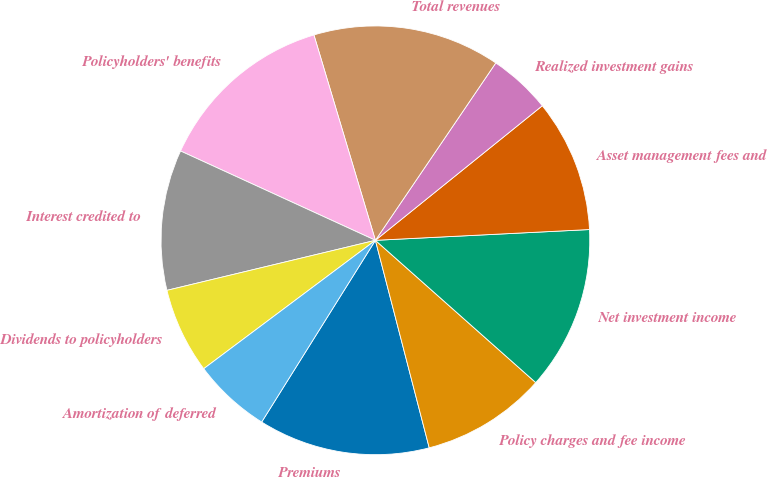Convert chart to OTSL. <chart><loc_0><loc_0><loc_500><loc_500><pie_chart><fcel>Premiums<fcel>Policy charges and fee income<fcel>Net investment income<fcel>Asset management fees and<fcel>Realized investment gains<fcel>Total revenues<fcel>Policyholders' benefits<fcel>Interest credited to<fcel>Dividends to policyholders<fcel>Amortization of deferred<nl><fcel>12.94%<fcel>9.41%<fcel>12.35%<fcel>10.0%<fcel>4.71%<fcel>14.12%<fcel>13.53%<fcel>10.59%<fcel>6.47%<fcel>5.88%<nl></chart> 